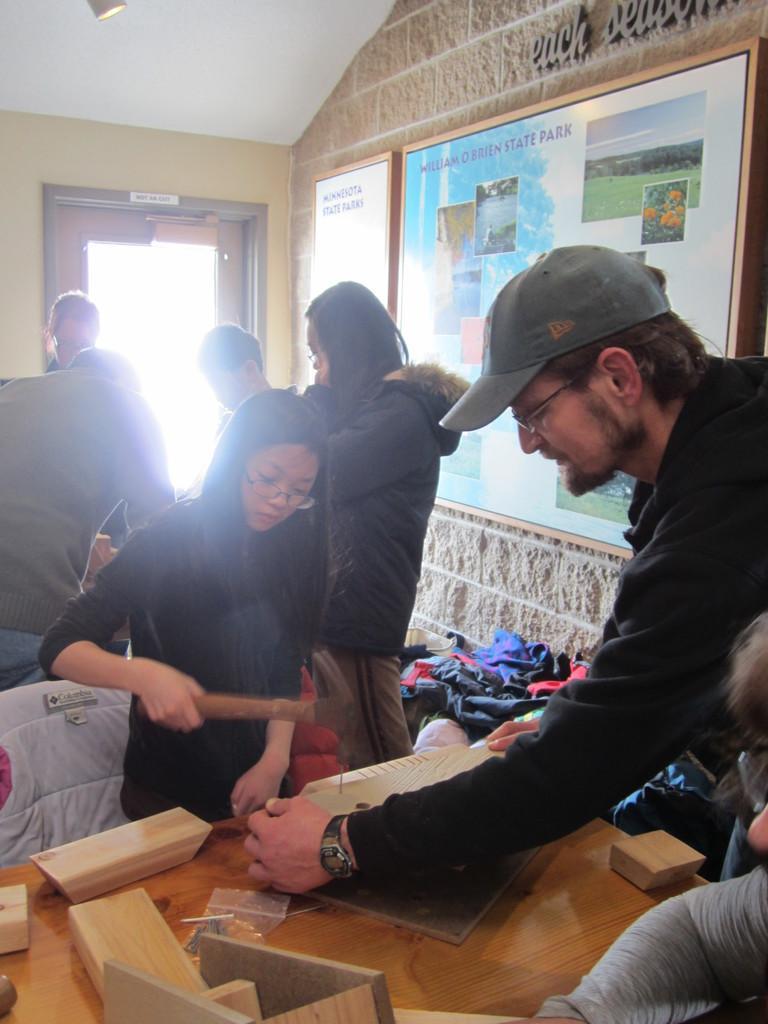Could you give a brief overview of what you see in this image? There is a girl and a man standing on either side of the tables on which some wooden pieces were placed. In the background there are some people standing. And we can observe a photo frame attached to the wall and a door here. 